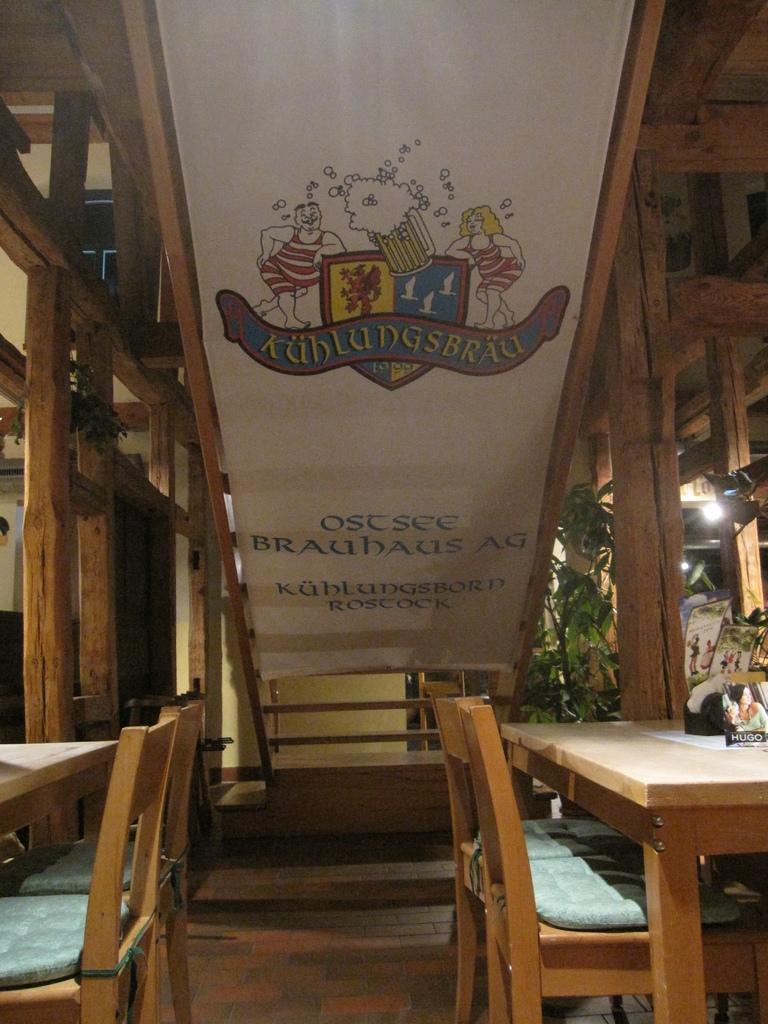Please provide a concise description of this image. In this image I can see the tables and chairs. To the right I can see few boards. In the background I can see few boards, plants, light and the wooden poles. 